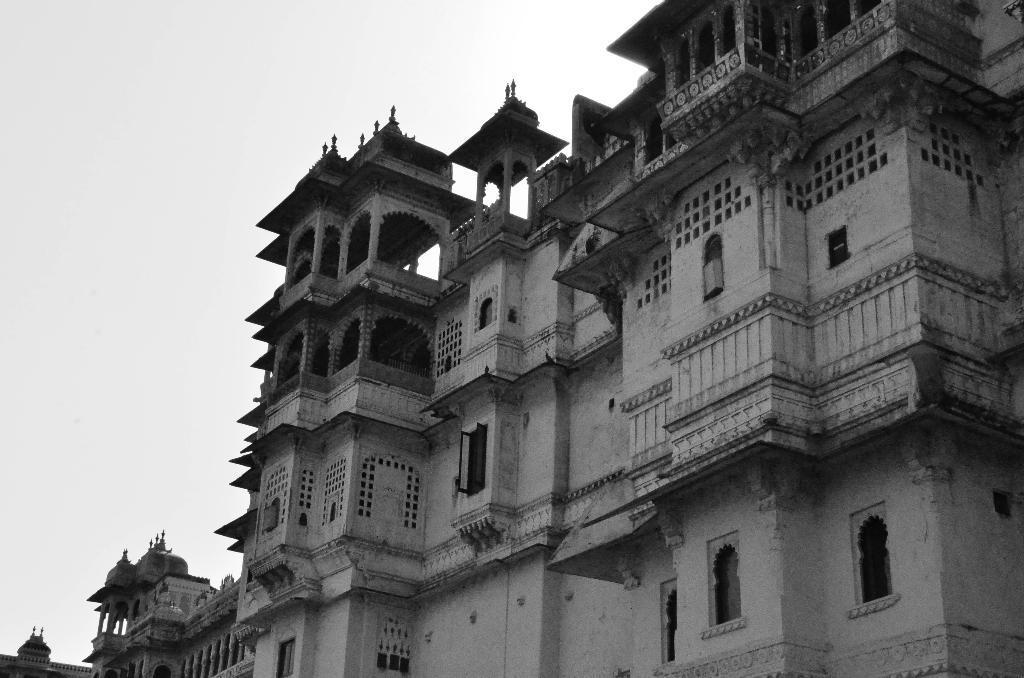Could you give a brief overview of what you see in this image? This is a black and white image. On the right side I can see a building along with the windows. At the top of the image I can see the sky. 